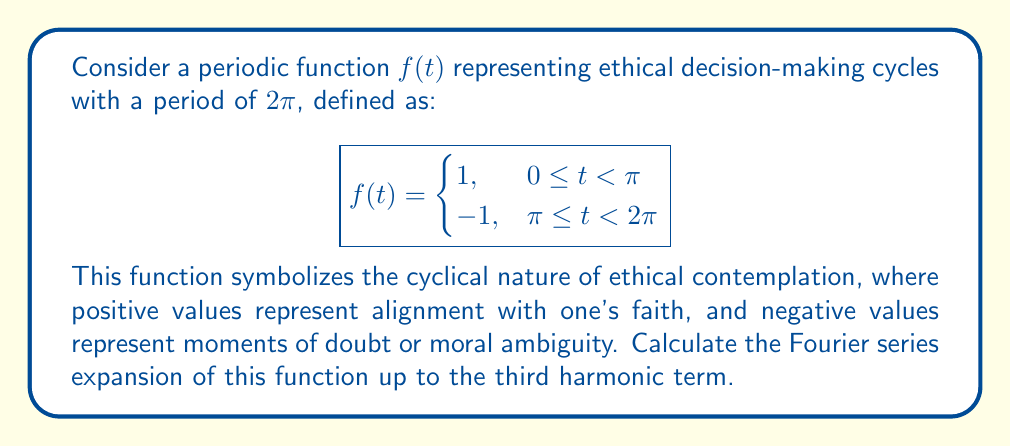Show me your answer to this math problem. To find the Fourier series expansion, we need to calculate the Fourier coefficients $a_0$, $a_n$, and $b_n$. The Fourier series is given by:

$$f(t) = \frac{a_0}{2} + \sum_{n=1}^{\infty} (a_n \cos(nt) + b_n \sin(nt))$$

Where:

$$a_0 = \frac{1}{\pi} \int_0^{2\pi} f(t) dt$$
$$a_n = \frac{1}{\pi} \int_0^{2\pi} f(t) \cos(nt) dt$$
$$b_n = \frac{1}{\pi} \int_0^{2\pi} f(t) \sin(nt) dt$$

1) Calculate $a_0$:
   $$a_0 = \frac{1}{\pi} \left(\int_0^{\pi} 1 dt + \int_{\pi}^{2\pi} (-1) dt\right) = \frac{1}{\pi} (\pi - \pi) = 0$$

2) Calculate $a_n$:
   $$a_n = \frac{1}{\pi} \left(\int_0^{\pi} \cos(nt) dt - \int_{\pi}^{2\pi} \cos(nt) dt\right) = 0$$
   This is because $\cos(nt)$ is an even function, and the integral cancels out over the full period.

3) Calculate $b_n$:
   $$b_n = \frac{1}{\pi} \left(\int_0^{\pi} \sin(nt) dt - \int_{\pi}^{2\pi} \sin(nt) dt\right)$$
   $$= \frac{1}{\pi} \left(-\frac{1}{n}\cos(nt)\bigg|_0^{\pi} + \frac{1}{n}\cos(nt)\bigg|_{\pi}^{2\pi}\right)$$
   $$= \frac{1}{\pi n} (-\cos(n\pi) + 1 + \cos(2n\pi) - \cos(n\pi))$$
   $$= \frac{2}{\pi n} (1 - \cos(n\pi)) = \begin{cases}
   \frac{4}{\pi n}, & \text{for odd } n \\
   0, & \text{for even } n
   \end{cases}$$

Therefore, the Fourier series expansion up to the third harmonic is:

$$f(t) = \frac{4}{\pi} \sin(t) + \frac{4}{3\pi} \sin(3t)$$

This series represents the ethical decision-making cycle as a sum of sinusoidal waves, with odd harmonics contributing to the sharp transitions between faith-aligned and doubt-filled periods.
Answer: $$f(t) = \frac{4}{\pi} \sin(t) + \frac{4}{3\pi} \sin(3t)$$ 